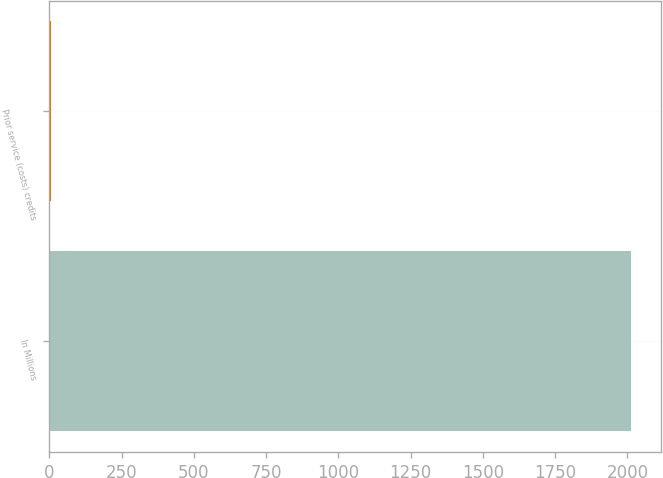Convert chart. <chart><loc_0><loc_0><loc_500><loc_500><bar_chart><fcel>In Millions<fcel>Prior service (costs) credits<nl><fcel>2014<fcel>4.4<nl></chart> 